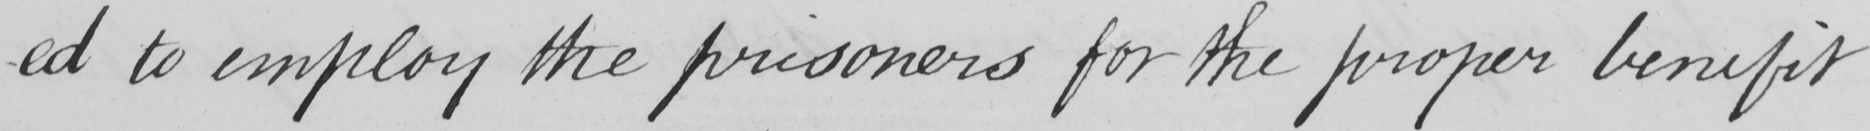Please transcribe the handwritten text in this image. -d to employ the prisoners for the proper benefit 